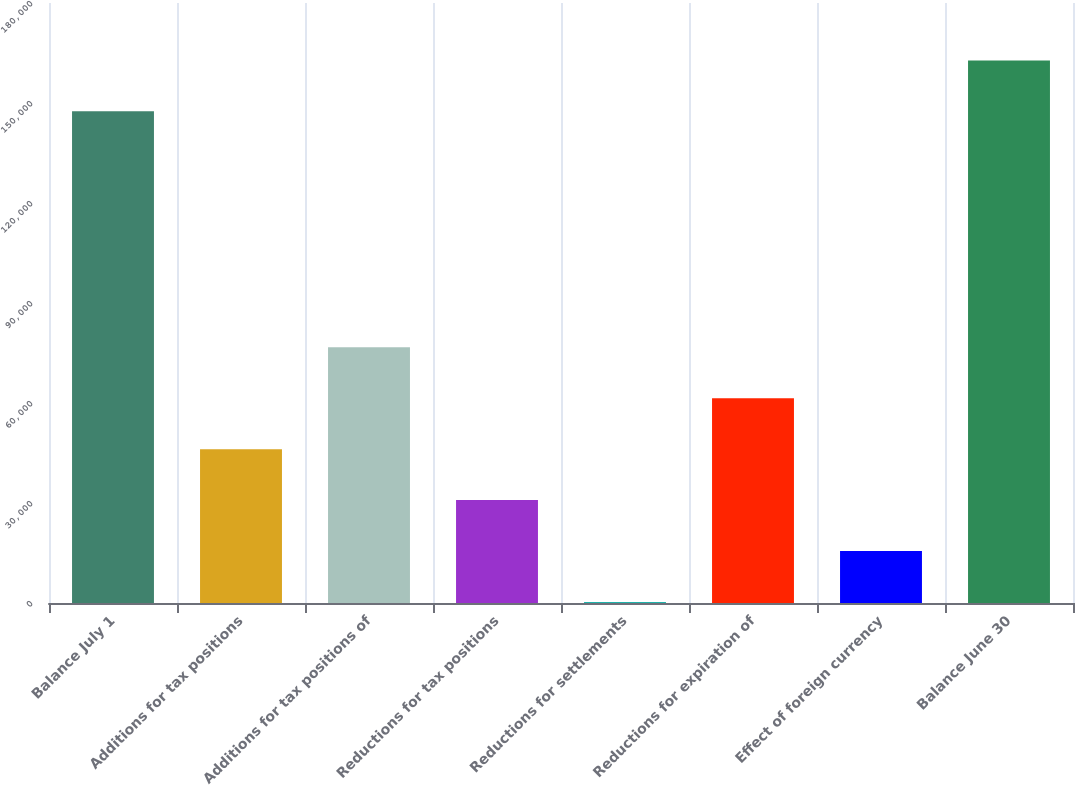<chart> <loc_0><loc_0><loc_500><loc_500><bar_chart><fcel>Balance July 1<fcel>Additions for tax positions<fcel>Additions for tax positions of<fcel>Reductions for tax positions<fcel>Reductions for settlements<fcel>Reductions for expiration of<fcel>Effect of foreign currency<fcel>Balance June 30<nl><fcel>147506<fcel>46147.8<fcel>76703<fcel>30870.2<fcel>315<fcel>61425.4<fcel>15592.6<fcel>162784<nl></chart> 